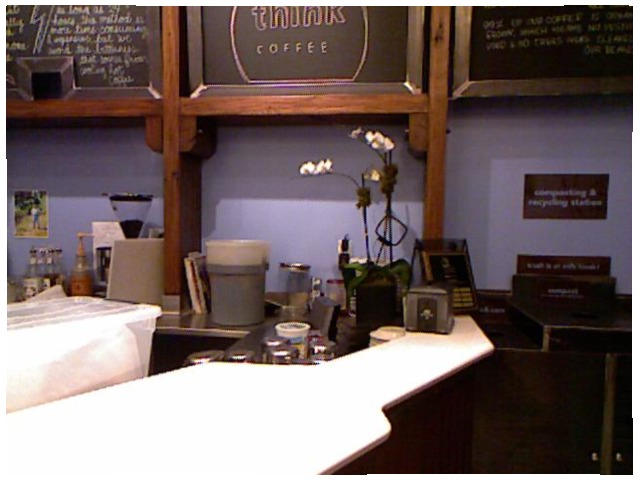<image>
Can you confirm if the box is in the shelf? No. The box is not contained within the shelf. These objects have a different spatial relationship. 